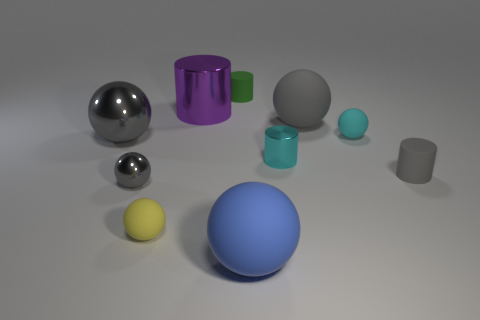Subtract all tiny shiny cylinders. How many cylinders are left? 3 Subtract all gray cylinders. How many cylinders are left? 3 Subtract 5 balls. How many balls are left? 1 Subtract all spheres. How many objects are left? 4 Subtract all cyan balls. How many blue cylinders are left? 0 Subtract all large purple spheres. Subtract all green matte cylinders. How many objects are left? 9 Add 6 purple objects. How many purple objects are left? 7 Add 5 tiny gray metallic spheres. How many tiny gray metallic spheres exist? 6 Subtract 1 cyan balls. How many objects are left? 9 Subtract all green spheres. Subtract all yellow cylinders. How many spheres are left? 6 